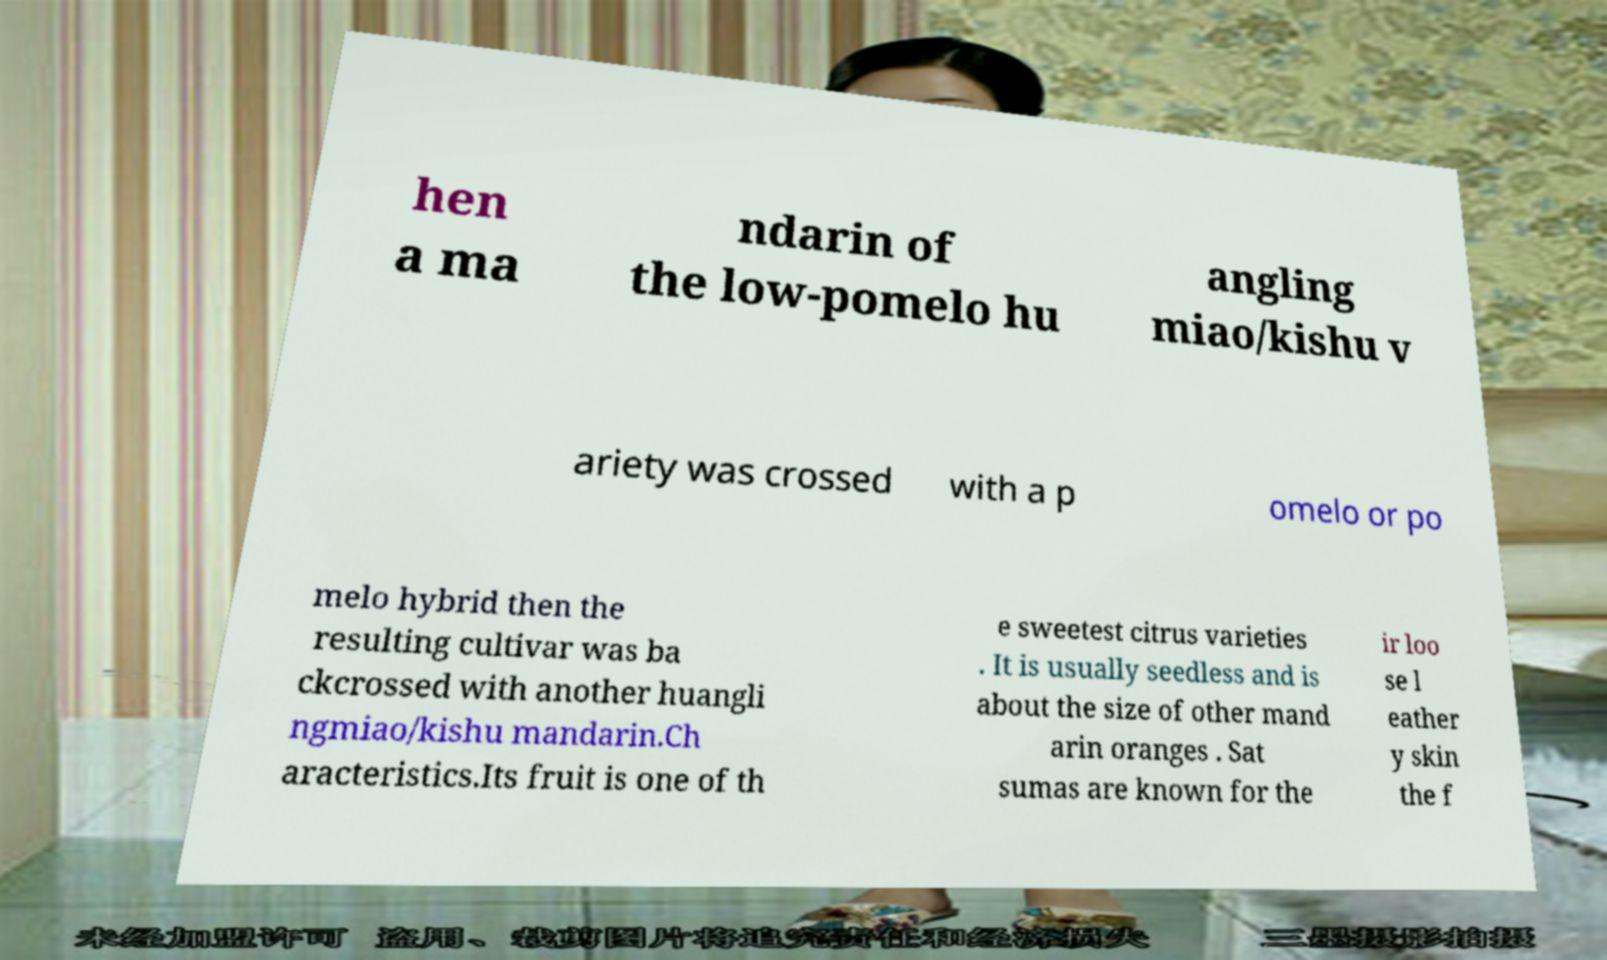What messages or text are displayed in this image? I need them in a readable, typed format. hen a ma ndarin of the low-pomelo hu angling miao/kishu v ariety was crossed with a p omelo or po melo hybrid then the resulting cultivar was ba ckcrossed with another huangli ngmiao/kishu mandarin.Ch aracteristics.Its fruit is one of th e sweetest citrus varieties . It is usually seedless and is about the size of other mand arin oranges . Sat sumas are known for the ir loo se l eather y skin the f 